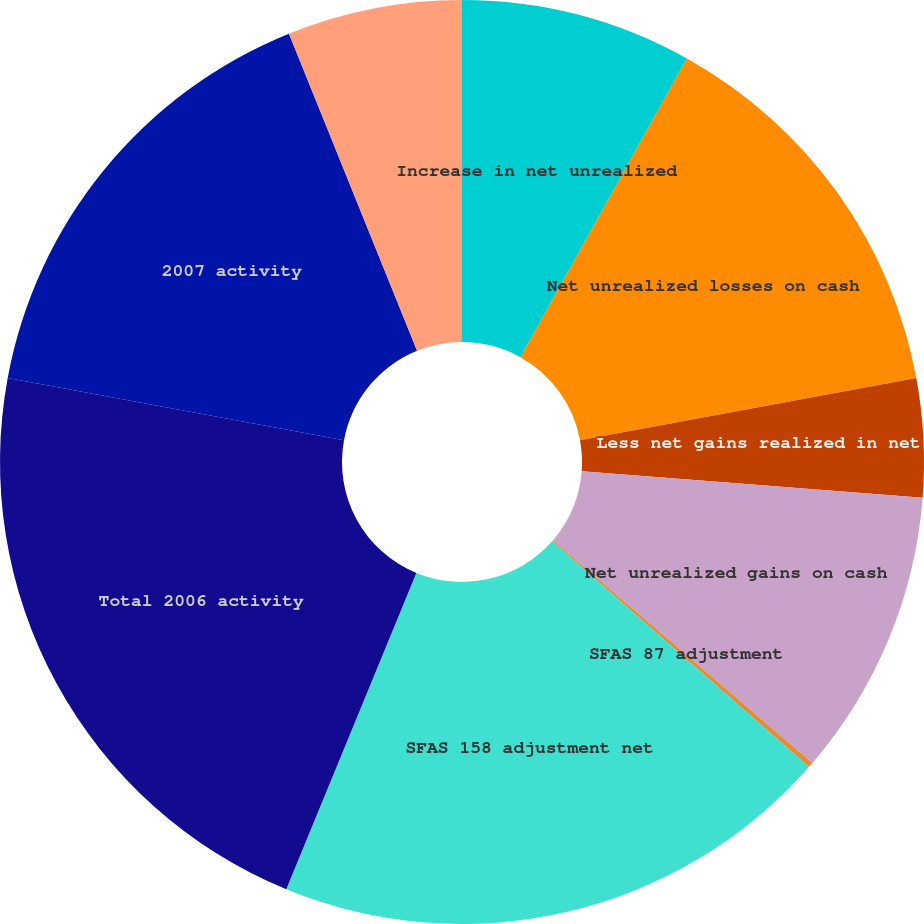Convert chart. <chart><loc_0><loc_0><loc_500><loc_500><pie_chart><fcel>Increase in net unrealized<fcel>Net unrealized losses on cash<fcel>Less net gains realized in net<fcel>Net unrealized gains on cash<fcel>SFAS 87 adjustment<fcel>SFAS 158 adjustment net<fcel>Total 2006 activity<fcel>2007 activity<fcel>2005 activity<nl><fcel>8.09%<fcel>14.0%<fcel>4.14%<fcel>10.06%<fcel>0.19%<fcel>19.73%<fcel>21.7%<fcel>15.98%<fcel>6.11%<nl></chart> 